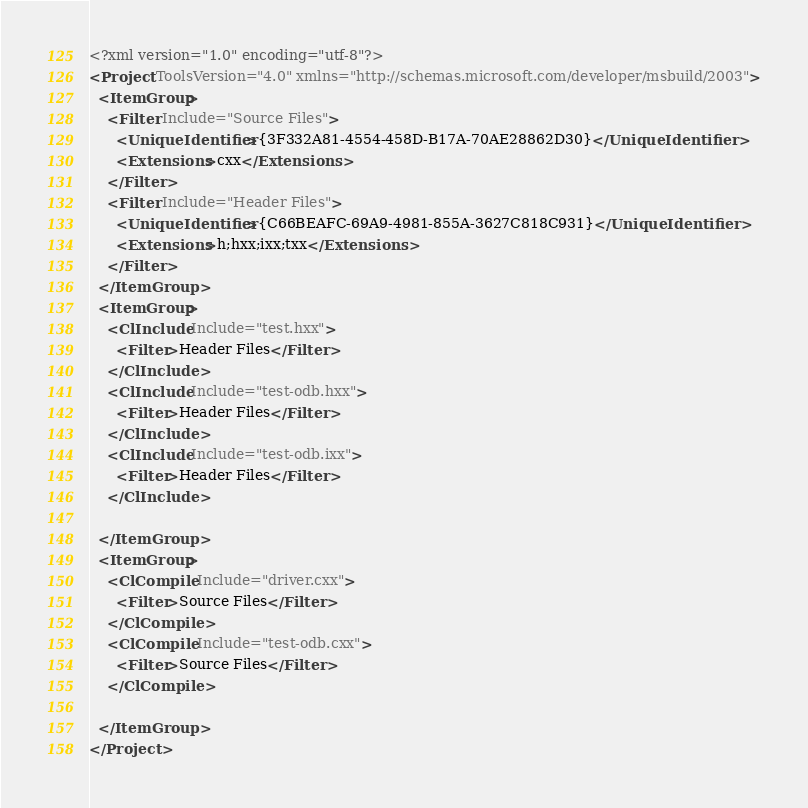Convert code to text. <code><loc_0><loc_0><loc_500><loc_500><_XML_><?xml version="1.0" encoding="utf-8"?>
<Project ToolsVersion="4.0" xmlns="http://schemas.microsoft.com/developer/msbuild/2003">
  <ItemGroup>
    <Filter Include="Source Files">
      <UniqueIdentifier>{3F332A81-4554-458D-B17A-70AE28862D30}</UniqueIdentifier>
      <Extensions>cxx</Extensions>
    </Filter>
    <Filter Include="Header Files">
      <UniqueIdentifier>{C66BEAFC-69A9-4981-855A-3627C818C931}</UniqueIdentifier>
      <Extensions>h;hxx;ixx;txx</Extensions>
    </Filter>
  </ItemGroup>
  <ItemGroup>
    <ClInclude Include="test.hxx">
      <Filter>Header Files</Filter>
    </ClInclude>
    <ClInclude Include="test-odb.hxx">
      <Filter>Header Files</Filter>
    </ClInclude>
    <ClInclude Include="test-odb.ixx">
      <Filter>Header Files</Filter>
    </ClInclude>

  </ItemGroup>
  <ItemGroup>
    <ClCompile Include="driver.cxx">
      <Filter>Source Files</Filter>
    </ClCompile>
    <ClCompile Include="test-odb.cxx">
      <Filter>Source Files</Filter>
    </ClCompile>

  </ItemGroup>
</Project>
</code> 